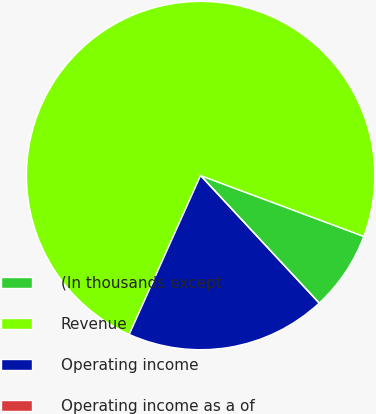Convert chart to OTSL. <chart><loc_0><loc_0><loc_500><loc_500><pie_chart><fcel>(In thousands except<fcel>Revenue<fcel>Operating income<fcel>Operating income as a of<nl><fcel>7.4%<fcel>73.97%<fcel>18.64%<fcel>0.0%<nl></chart> 